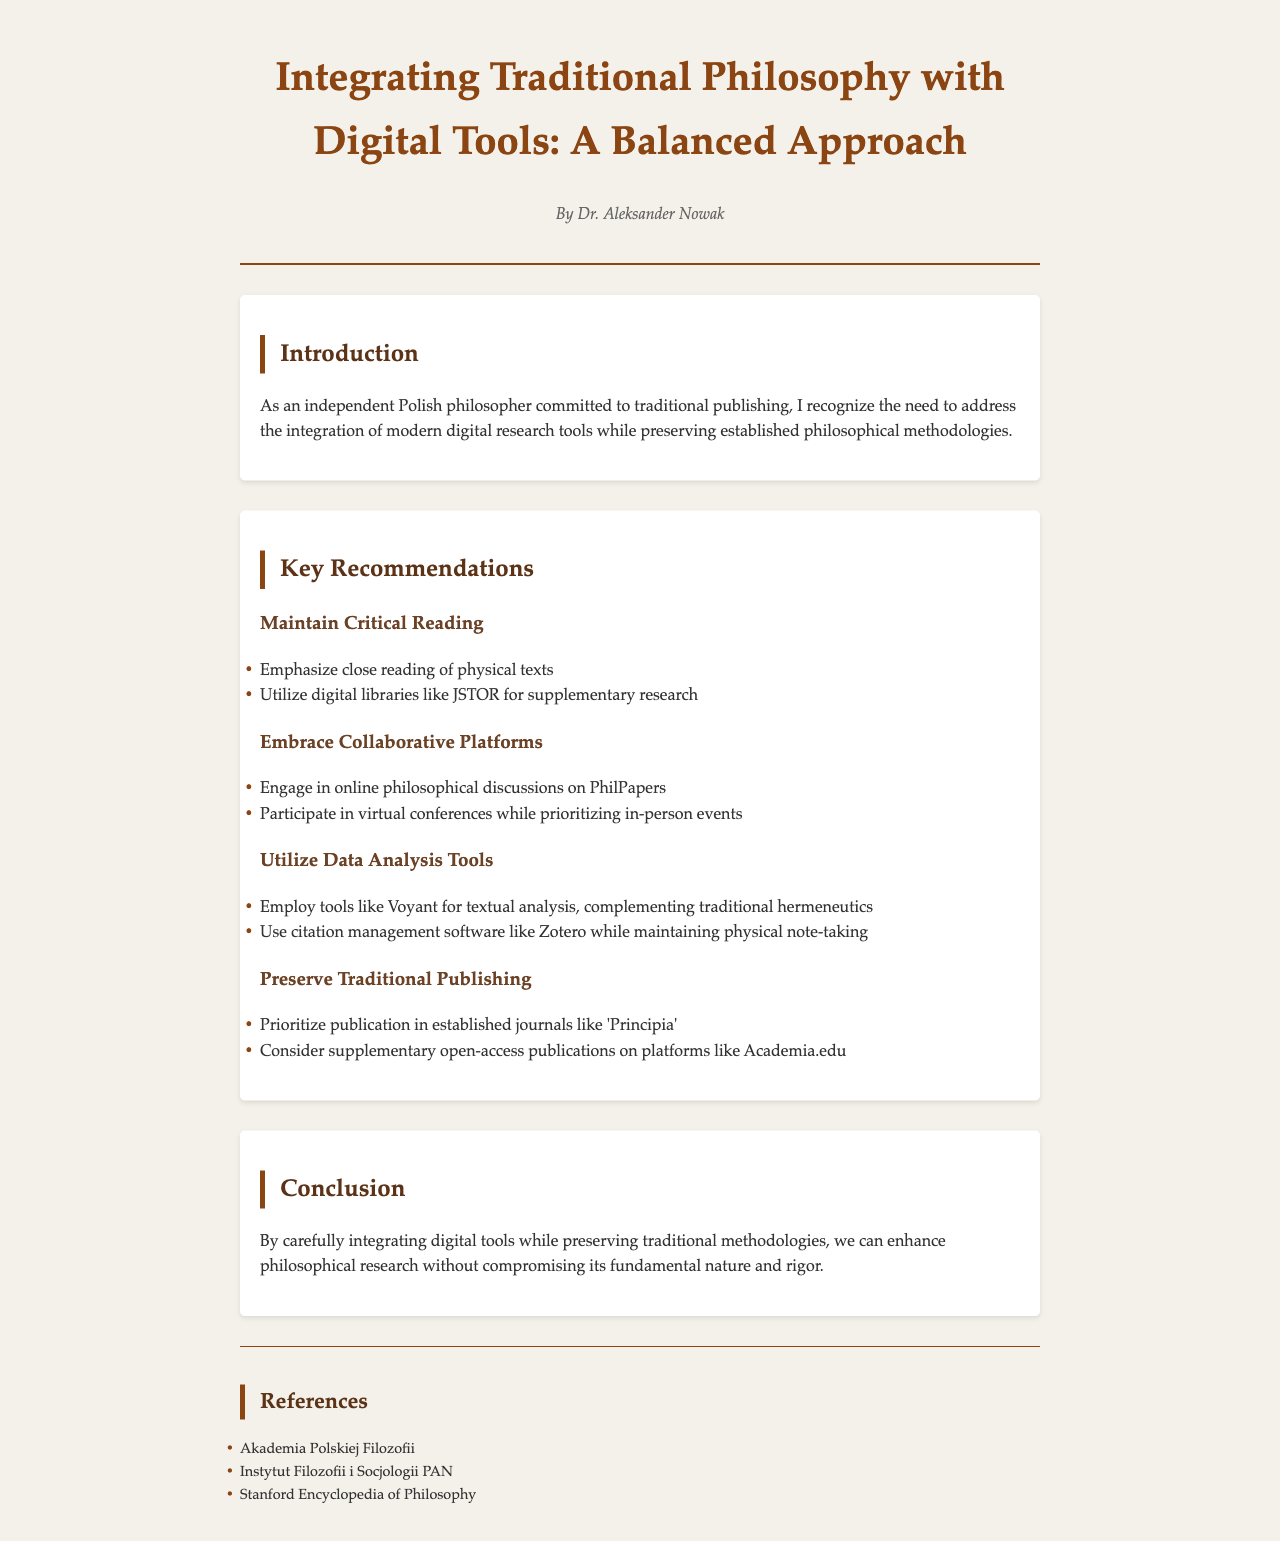What is the title of the document? The title appears prominently at the top of the document, indicating the central theme about the integration of traditional and digital methodologies.
Answer: Integrating Traditional Philosophy with Digital Tools: A Balanced Approach Who is the author of the document? The author's name is presented under the title, indicating the individual responsible for the document's content.
Answer: Dr. Aleksander Nowak What is one of the key recommendations regarding traditional texts? The document lists recommendations which include the approach to traditional texts, showcasing the importance of this practice in philosophical research.
Answer: Emphasize close reading of physical texts Which digital platform is recommended for online philosophical discussions? The document suggests specific platforms for enhancing philosophical dialogue, indicating the preferred medium for collaboration.
Answer: PhilPapers What citation management software is mentioned? This software is highlighted within the recommendations section, indicating the tools that can be utilized alongside traditional methods.
Answer: Zotero What is emphasized in the conclusion of the document? The conclusion summarizes the document's key theme, indicating the overall approach to integrating methodologies.
Answer: Enhance philosophical research without compromising its fundamental nature and rigor What type of publishing does the author prioritize? The author emphasizes a specific type of publication in the recommendations, showcasing the document's adherence to traditional practices.
Answer: Established journals like 'Principia' What are two sources listed in the references? The references provide additional materials and institutions that support the document's content, serving as foundational texts in philosophy.
Answer: Akademia Polskiej Filozofii, Instytut Filozofii i Socjologii PAN 